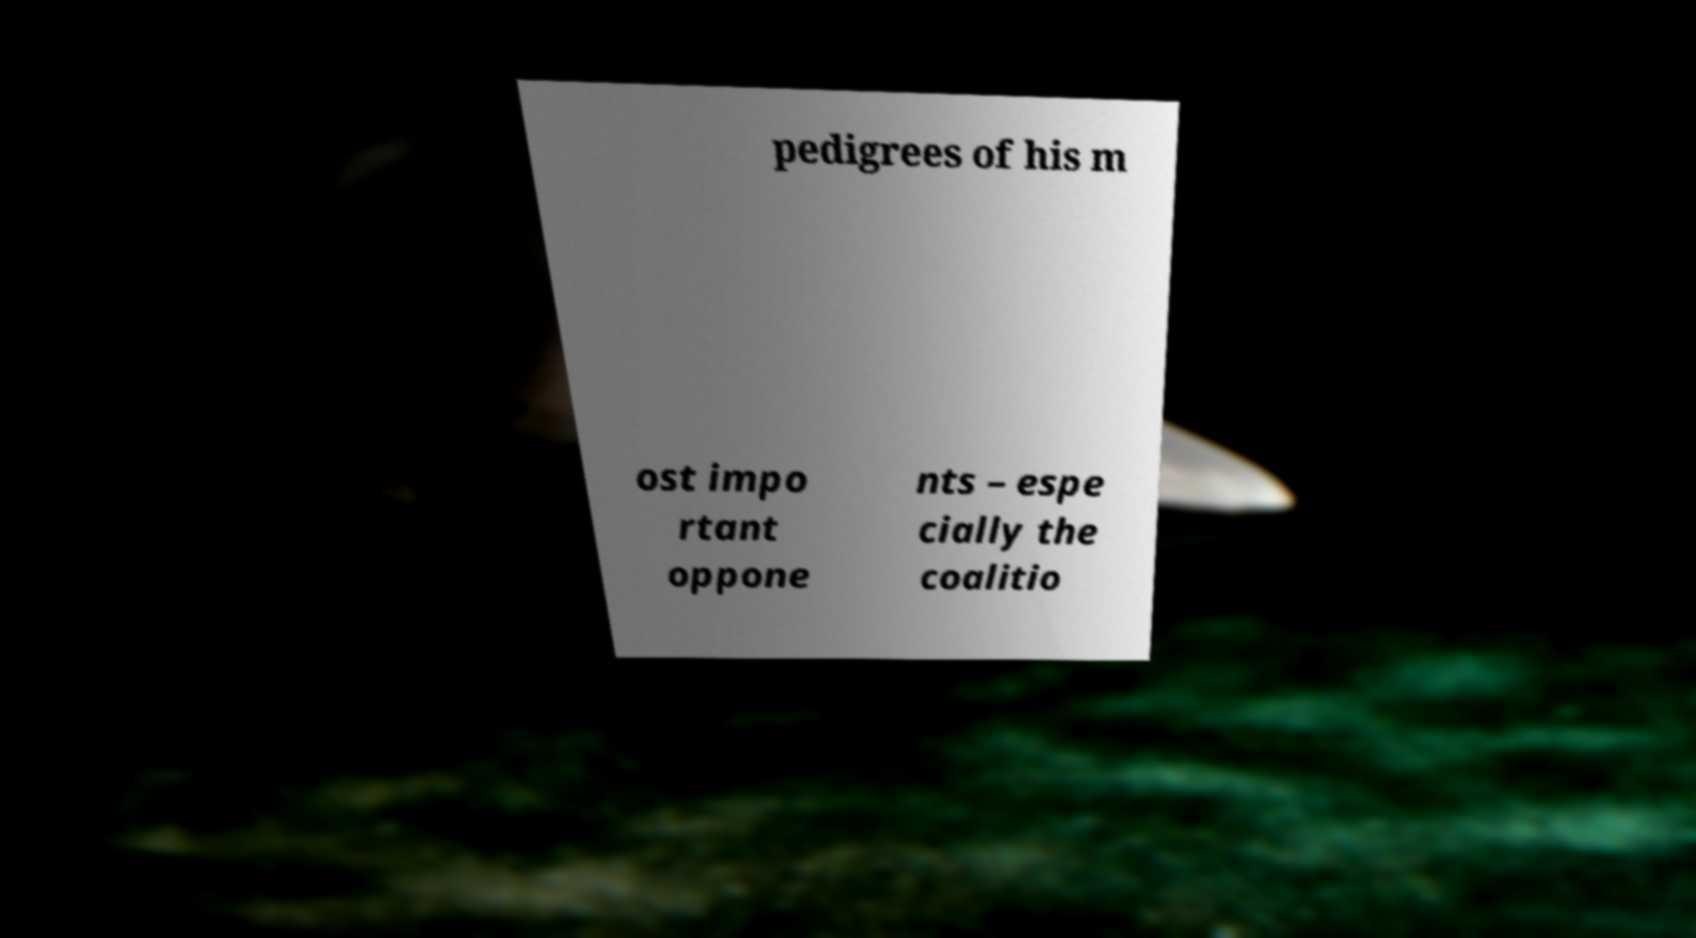What messages or text are displayed in this image? I need them in a readable, typed format. pedigrees of his m ost impo rtant oppone nts – espe cially the coalitio 